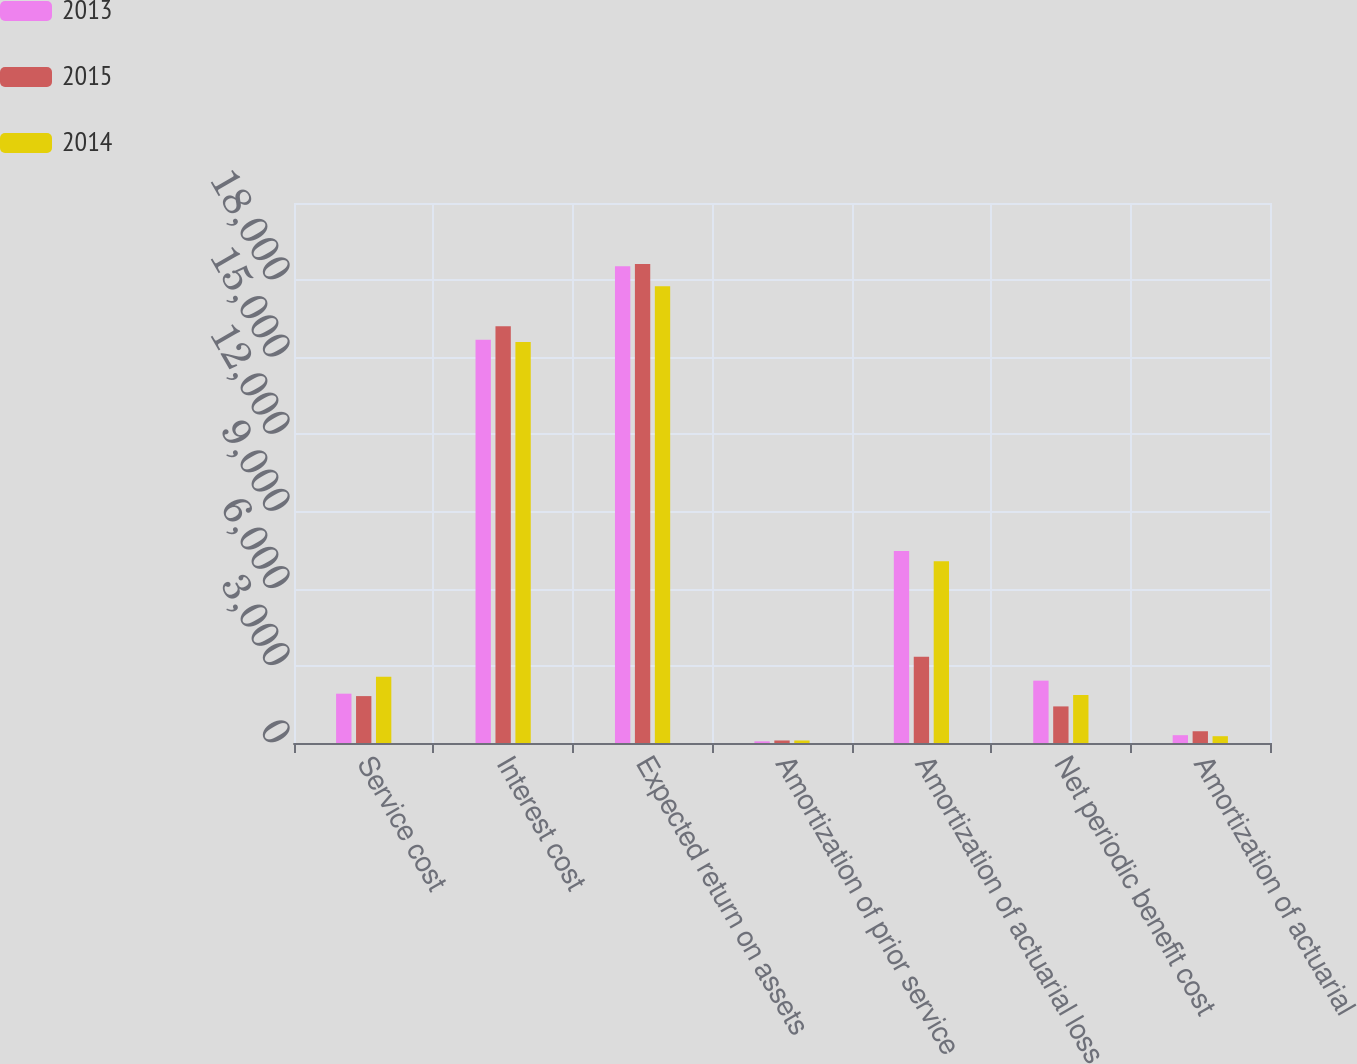<chart> <loc_0><loc_0><loc_500><loc_500><stacked_bar_chart><ecel><fcel>Service cost<fcel>Interest cost<fcel>Expected return on assets<fcel>Amortization of prior service<fcel>Amortization of actuarial loss<fcel>Net periodic benefit cost<fcel>Amortization of actuarial<nl><fcel>2013<fcel>1918<fcel>15683<fcel>18538<fcel>65<fcel>7468<fcel>2425<fcel>304<nl><fcel>2015<fcel>1824<fcel>16209<fcel>18631<fcel>98<fcel>3351<fcel>1423<fcel>457<nl><fcel>2014<fcel>2579<fcel>15597<fcel>17761<fcel>98<fcel>7070<fcel>1866<fcel>264<nl></chart> 